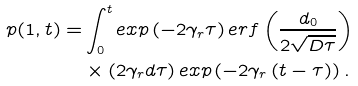Convert formula to latex. <formula><loc_0><loc_0><loc_500><loc_500>p ( 1 , t ) = & \int _ { 0 } ^ { t } e x p \left ( - 2 \gamma _ { r } \tau \right ) e r f \left ( \frac { d _ { 0 } } { 2 \sqrt { D \tau } } \right ) \\ & \times \left ( 2 \gamma _ { r } d \tau \right ) e x p \left ( - 2 \gamma _ { r } \left ( t - \tau \right ) \right ) .</formula> 